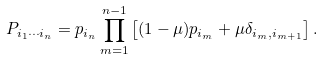Convert formula to latex. <formula><loc_0><loc_0><loc_500><loc_500>P _ { i _ { 1 } \cdots i _ { n } } = p _ { i _ { n } } \prod _ { m = 1 } ^ { n - 1 } \left [ ( 1 - \mu ) p _ { i _ { m } } + \mu \delta _ { i _ { m } , i _ { m + 1 } } \right ] .</formula> 